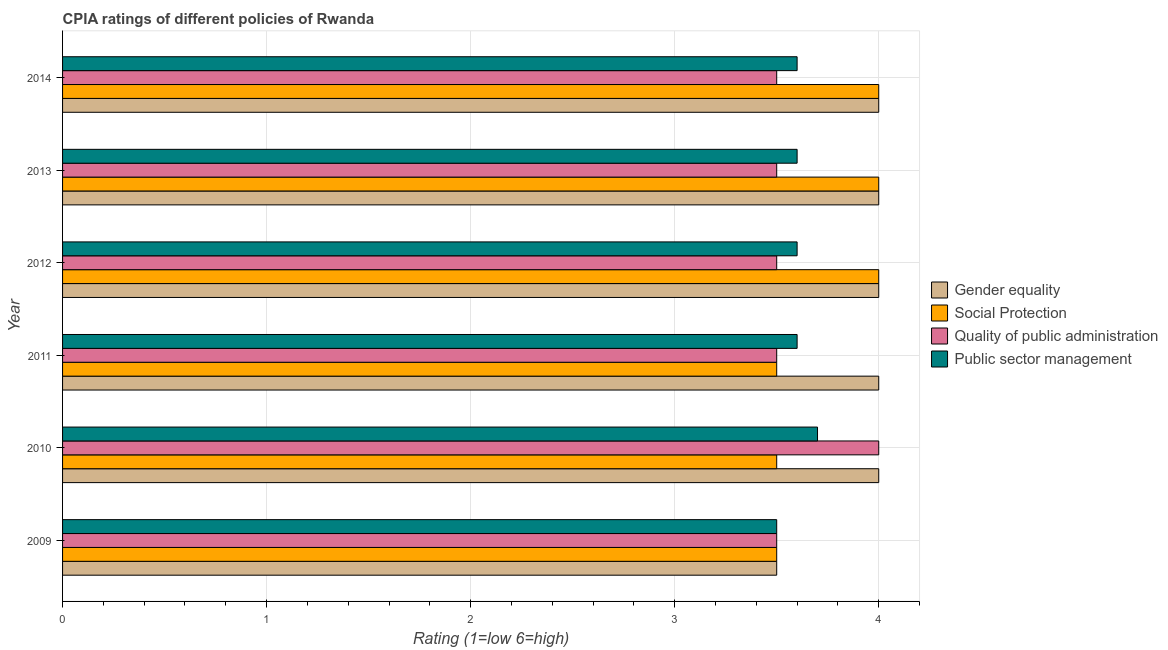How many groups of bars are there?
Give a very brief answer. 6. Are the number of bars on each tick of the Y-axis equal?
Your answer should be very brief. Yes. How many bars are there on the 5th tick from the top?
Offer a very short reply. 4. What is the cpia rating of gender equality in 2010?
Offer a very short reply. 4. In which year was the cpia rating of quality of public administration minimum?
Make the answer very short. 2009. What is the difference between the cpia rating of quality of public administration in 2014 and the cpia rating of gender equality in 2010?
Ensure brevity in your answer.  -0.5. What is the average cpia rating of public sector management per year?
Make the answer very short. 3.6. In how many years, is the cpia rating of gender equality greater than 1.8 ?
Offer a terse response. 6. What is the ratio of the cpia rating of gender equality in 2009 to that in 2014?
Your answer should be compact. 0.88. Is the cpia rating of social protection in 2009 less than that in 2010?
Keep it short and to the point. No. Is the difference between the cpia rating of social protection in 2009 and 2011 greater than the difference between the cpia rating of public sector management in 2009 and 2011?
Make the answer very short. Yes. What does the 1st bar from the top in 2013 represents?
Your response must be concise. Public sector management. What does the 4th bar from the bottom in 2012 represents?
Ensure brevity in your answer.  Public sector management. How many bars are there?
Offer a terse response. 24. Are all the bars in the graph horizontal?
Provide a short and direct response. Yes. What is the difference between two consecutive major ticks on the X-axis?
Make the answer very short. 1. How many legend labels are there?
Your response must be concise. 4. What is the title of the graph?
Provide a short and direct response. CPIA ratings of different policies of Rwanda. Does "Public sector management" appear as one of the legend labels in the graph?
Offer a terse response. Yes. What is the label or title of the X-axis?
Your answer should be very brief. Rating (1=low 6=high). What is the Rating (1=low 6=high) in Gender equality in 2009?
Make the answer very short. 3.5. What is the Rating (1=low 6=high) in Social Protection in 2009?
Your answer should be very brief. 3.5. What is the Rating (1=low 6=high) of Quality of public administration in 2009?
Offer a very short reply. 3.5. What is the Rating (1=low 6=high) in Gender equality in 2010?
Offer a very short reply. 4. What is the Rating (1=low 6=high) in Quality of public administration in 2010?
Your response must be concise. 4. What is the Rating (1=low 6=high) of Public sector management in 2010?
Provide a succinct answer. 3.7. What is the Rating (1=low 6=high) in Social Protection in 2011?
Offer a terse response. 3.5. What is the Rating (1=low 6=high) in Public sector management in 2011?
Keep it short and to the point. 3.6. What is the Rating (1=low 6=high) in Quality of public administration in 2012?
Keep it short and to the point. 3.5. What is the Rating (1=low 6=high) in Public sector management in 2012?
Ensure brevity in your answer.  3.6. What is the Rating (1=low 6=high) in Gender equality in 2013?
Your response must be concise. 4. What is the Rating (1=low 6=high) in Public sector management in 2013?
Your answer should be very brief. 3.6. What is the Rating (1=low 6=high) of Social Protection in 2014?
Keep it short and to the point. 4. What is the Rating (1=low 6=high) in Quality of public administration in 2014?
Keep it short and to the point. 3.5. Across all years, what is the maximum Rating (1=low 6=high) of Social Protection?
Offer a terse response. 4. Across all years, what is the maximum Rating (1=low 6=high) of Quality of public administration?
Your answer should be compact. 4. Across all years, what is the maximum Rating (1=low 6=high) of Public sector management?
Make the answer very short. 3.7. Across all years, what is the minimum Rating (1=low 6=high) of Social Protection?
Offer a very short reply. 3.5. Across all years, what is the minimum Rating (1=low 6=high) of Quality of public administration?
Your answer should be very brief. 3.5. What is the total Rating (1=low 6=high) in Social Protection in the graph?
Offer a very short reply. 22.5. What is the total Rating (1=low 6=high) of Public sector management in the graph?
Make the answer very short. 21.6. What is the difference between the Rating (1=low 6=high) in Social Protection in 2009 and that in 2010?
Your answer should be very brief. 0. What is the difference between the Rating (1=low 6=high) in Quality of public administration in 2009 and that in 2010?
Ensure brevity in your answer.  -0.5. What is the difference between the Rating (1=low 6=high) in Public sector management in 2009 and that in 2010?
Ensure brevity in your answer.  -0.2. What is the difference between the Rating (1=low 6=high) of Gender equality in 2009 and that in 2011?
Provide a succinct answer. -0.5. What is the difference between the Rating (1=low 6=high) of Social Protection in 2009 and that in 2011?
Offer a terse response. 0. What is the difference between the Rating (1=low 6=high) in Quality of public administration in 2009 and that in 2011?
Your response must be concise. 0. What is the difference between the Rating (1=low 6=high) of Gender equality in 2009 and that in 2013?
Give a very brief answer. -0.5. What is the difference between the Rating (1=low 6=high) of Quality of public administration in 2009 and that in 2013?
Keep it short and to the point. 0. What is the difference between the Rating (1=low 6=high) of Public sector management in 2009 and that in 2013?
Give a very brief answer. -0.1. What is the difference between the Rating (1=low 6=high) of Social Protection in 2009 and that in 2014?
Give a very brief answer. -0.5. What is the difference between the Rating (1=low 6=high) in Gender equality in 2010 and that in 2011?
Your answer should be very brief. 0. What is the difference between the Rating (1=low 6=high) of Social Protection in 2010 and that in 2011?
Provide a succinct answer. 0. What is the difference between the Rating (1=low 6=high) of Public sector management in 2010 and that in 2011?
Your response must be concise. 0.1. What is the difference between the Rating (1=low 6=high) of Social Protection in 2010 and that in 2012?
Offer a terse response. -0.5. What is the difference between the Rating (1=low 6=high) of Quality of public administration in 2010 and that in 2012?
Your response must be concise. 0.5. What is the difference between the Rating (1=low 6=high) of Public sector management in 2010 and that in 2012?
Offer a terse response. 0.1. What is the difference between the Rating (1=low 6=high) of Social Protection in 2010 and that in 2014?
Offer a terse response. -0.5. What is the difference between the Rating (1=low 6=high) in Quality of public administration in 2011 and that in 2012?
Offer a terse response. 0. What is the difference between the Rating (1=low 6=high) of Public sector management in 2011 and that in 2012?
Offer a very short reply. 0. What is the difference between the Rating (1=low 6=high) of Gender equality in 2011 and that in 2013?
Provide a succinct answer. 0. What is the difference between the Rating (1=low 6=high) of Quality of public administration in 2011 and that in 2013?
Give a very brief answer. 0. What is the difference between the Rating (1=low 6=high) of Quality of public administration in 2011 and that in 2014?
Provide a succinct answer. 0. What is the difference between the Rating (1=low 6=high) of Gender equality in 2012 and that in 2013?
Keep it short and to the point. 0. What is the difference between the Rating (1=low 6=high) in Social Protection in 2012 and that in 2013?
Your answer should be compact. 0. What is the difference between the Rating (1=low 6=high) in Gender equality in 2012 and that in 2014?
Keep it short and to the point. 0. What is the difference between the Rating (1=low 6=high) of Social Protection in 2012 and that in 2014?
Your answer should be very brief. 0. What is the difference between the Rating (1=low 6=high) in Public sector management in 2012 and that in 2014?
Keep it short and to the point. 0. What is the difference between the Rating (1=low 6=high) of Gender equality in 2009 and the Rating (1=low 6=high) of Public sector management in 2010?
Provide a succinct answer. -0.2. What is the difference between the Rating (1=low 6=high) in Social Protection in 2009 and the Rating (1=low 6=high) in Quality of public administration in 2010?
Your response must be concise. -0.5. What is the difference between the Rating (1=low 6=high) in Social Protection in 2009 and the Rating (1=low 6=high) in Public sector management in 2010?
Keep it short and to the point. -0.2. What is the difference between the Rating (1=low 6=high) of Quality of public administration in 2009 and the Rating (1=low 6=high) of Public sector management in 2010?
Your response must be concise. -0.2. What is the difference between the Rating (1=low 6=high) in Gender equality in 2009 and the Rating (1=low 6=high) in Social Protection in 2011?
Your answer should be compact. 0. What is the difference between the Rating (1=low 6=high) of Gender equality in 2009 and the Rating (1=low 6=high) of Public sector management in 2011?
Your answer should be very brief. -0.1. What is the difference between the Rating (1=low 6=high) of Social Protection in 2009 and the Rating (1=low 6=high) of Quality of public administration in 2011?
Ensure brevity in your answer.  0. What is the difference between the Rating (1=low 6=high) in Social Protection in 2009 and the Rating (1=low 6=high) in Public sector management in 2011?
Give a very brief answer. -0.1. What is the difference between the Rating (1=low 6=high) in Gender equality in 2009 and the Rating (1=low 6=high) in Social Protection in 2012?
Your response must be concise. -0.5. What is the difference between the Rating (1=low 6=high) in Gender equality in 2009 and the Rating (1=low 6=high) in Public sector management in 2012?
Keep it short and to the point. -0.1. What is the difference between the Rating (1=low 6=high) of Social Protection in 2009 and the Rating (1=low 6=high) of Quality of public administration in 2012?
Your answer should be very brief. 0. What is the difference between the Rating (1=low 6=high) of Social Protection in 2009 and the Rating (1=low 6=high) of Public sector management in 2012?
Your response must be concise. -0.1. What is the difference between the Rating (1=low 6=high) in Social Protection in 2009 and the Rating (1=low 6=high) in Public sector management in 2013?
Your answer should be compact. -0.1. What is the difference between the Rating (1=low 6=high) of Quality of public administration in 2009 and the Rating (1=low 6=high) of Public sector management in 2013?
Provide a short and direct response. -0.1. What is the difference between the Rating (1=low 6=high) of Gender equality in 2009 and the Rating (1=low 6=high) of Social Protection in 2014?
Make the answer very short. -0.5. What is the difference between the Rating (1=low 6=high) of Quality of public administration in 2009 and the Rating (1=low 6=high) of Public sector management in 2014?
Provide a short and direct response. -0.1. What is the difference between the Rating (1=low 6=high) of Gender equality in 2010 and the Rating (1=low 6=high) of Social Protection in 2011?
Offer a very short reply. 0.5. What is the difference between the Rating (1=low 6=high) in Social Protection in 2010 and the Rating (1=low 6=high) in Quality of public administration in 2011?
Your answer should be compact. 0. What is the difference between the Rating (1=low 6=high) in Quality of public administration in 2010 and the Rating (1=low 6=high) in Public sector management in 2011?
Keep it short and to the point. 0.4. What is the difference between the Rating (1=low 6=high) of Social Protection in 2010 and the Rating (1=low 6=high) of Quality of public administration in 2012?
Offer a terse response. 0. What is the difference between the Rating (1=low 6=high) of Gender equality in 2010 and the Rating (1=low 6=high) of Social Protection in 2013?
Offer a terse response. 0. What is the difference between the Rating (1=low 6=high) in Social Protection in 2010 and the Rating (1=low 6=high) in Public sector management in 2013?
Offer a very short reply. -0.1. What is the difference between the Rating (1=low 6=high) in Quality of public administration in 2010 and the Rating (1=low 6=high) in Public sector management in 2013?
Give a very brief answer. 0.4. What is the difference between the Rating (1=low 6=high) of Gender equality in 2010 and the Rating (1=low 6=high) of Social Protection in 2014?
Your answer should be compact. 0. What is the difference between the Rating (1=low 6=high) of Gender equality in 2010 and the Rating (1=low 6=high) of Quality of public administration in 2014?
Offer a very short reply. 0.5. What is the difference between the Rating (1=low 6=high) of Quality of public administration in 2010 and the Rating (1=low 6=high) of Public sector management in 2014?
Give a very brief answer. 0.4. What is the difference between the Rating (1=low 6=high) of Gender equality in 2011 and the Rating (1=low 6=high) of Public sector management in 2012?
Ensure brevity in your answer.  0.4. What is the difference between the Rating (1=low 6=high) of Social Protection in 2011 and the Rating (1=low 6=high) of Quality of public administration in 2012?
Give a very brief answer. 0. What is the difference between the Rating (1=low 6=high) of Quality of public administration in 2011 and the Rating (1=low 6=high) of Public sector management in 2012?
Provide a short and direct response. -0.1. What is the difference between the Rating (1=low 6=high) in Gender equality in 2011 and the Rating (1=low 6=high) in Social Protection in 2013?
Your answer should be compact. 0. What is the difference between the Rating (1=low 6=high) in Gender equality in 2011 and the Rating (1=low 6=high) in Public sector management in 2013?
Your response must be concise. 0.4. What is the difference between the Rating (1=low 6=high) in Quality of public administration in 2011 and the Rating (1=low 6=high) in Public sector management in 2013?
Offer a terse response. -0.1. What is the difference between the Rating (1=low 6=high) in Gender equality in 2011 and the Rating (1=low 6=high) in Social Protection in 2014?
Your response must be concise. 0. What is the difference between the Rating (1=low 6=high) in Gender equality in 2011 and the Rating (1=low 6=high) in Quality of public administration in 2014?
Your answer should be compact. 0.5. What is the difference between the Rating (1=low 6=high) in Social Protection in 2011 and the Rating (1=low 6=high) in Quality of public administration in 2014?
Your answer should be compact. 0. What is the difference between the Rating (1=low 6=high) in Quality of public administration in 2011 and the Rating (1=low 6=high) in Public sector management in 2014?
Keep it short and to the point. -0.1. What is the difference between the Rating (1=low 6=high) of Gender equality in 2012 and the Rating (1=low 6=high) of Social Protection in 2013?
Provide a succinct answer. 0. What is the difference between the Rating (1=low 6=high) of Gender equality in 2012 and the Rating (1=low 6=high) of Quality of public administration in 2013?
Provide a short and direct response. 0.5. What is the difference between the Rating (1=low 6=high) in Gender equality in 2012 and the Rating (1=low 6=high) in Social Protection in 2014?
Give a very brief answer. 0. What is the difference between the Rating (1=low 6=high) in Gender equality in 2012 and the Rating (1=low 6=high) in Quality of public administration in 2014?
Your answer should be compact. 0.5. What is the difference between the Rating (1=low 6=high) of Quality of public administration in 2012 and the Rating (1=low 6=high) of Public sector management in 2014?
Offer a terse response. -0.1. What is the difference between the Rating (1=low 6=high) of Gender equality in 2013 and the Rating (1=low 6=high) of Social Protection in 2014?
Ensure brevity in your answer.  0. What is the difference between the Rating (1=low 6=high) of Social Protection in 2013 and the Rating (1=low 6=high) of Public sector management in 2014?
Ensure brevity in your answer.  0.4. What is the difference between the Rating (1=low 6=high) in Quality of public administration in 2013 and the Rating (1=low 6=high) in Public sector management in 2014?
Offer a terse response. -0.1. What is the average Rating (1=low 6=high) of Gender equality per year?
Ensure brevity in your answer.  3.92. What is the average Rating (1=low 6=high) of Social Protection per year?
Your response must be concise. 3.75. What is the average Rating (1=low 6=high) in Quality of public administration per year?
Make the answer very short. 3.58. What is the average Rating (1=low 6=high) in Public sector management per year?
Your answer should be compact. 3.6. In the year 2009, what is the difference between the Rating (1=low 6=high) in Gender equality and Rating (1=low 6=high) in Quality of public administration?
Your answer should be very brief. 0. In the year 2009, what is the difference between the Rating (1=low 6=high) in Social Protection and Rating (1=low 6=high) in Quality of public administration?
Ensure brevity in your answer.  0. In the year 2010, what is the difference between the Rating (1=low 6=high) in Gender equality and Rating (1=low 6=high) in Quality of public administration?
Offer a very short reply. 0. In the year 2010, what is the difference between the Rating (1=low 6=high) in Social Protection and Rating (1=low 6=high) in Public sector management?
Provide a short and direct response. -0.2. In the year 2010, what is the difference between the Rating (1=low 6=high) in Quality of public administration and Rating (1=low 6=high) in Public sector management?
Provide a short and direct response. 0.3. In the year 2011, what is the difference between the Rating (1=low 6=high) of Gender equality and Rating (1=low 6=high) of Social Protection?
Provide a succinct answer. 0.5. In the year 2011, what is the difference between the Rating (1=low 6=high) in Gender equality and Rating (1=low 6=high) in Quality of public administration?
Ensure brevity in your answer.  0.5. In the year 2011, what is the difference between the Rating (1=low 6=high) in Social Protection and Rating (1=low 6=high) in Quality of public administration?
Offer a very short reply. 0. In the year 2011, what is the difference between the Rating (1=low 6=high) in Social Protection and Rating (1=low 6=high) in Public sector management?
Offer a very short reply. -0.1. In the year 2011, what is the difference between the Rating (1=low 6=high) of Quality of public administration and Rating (1=low 6=high) of Public sector management?
Offer a terse response. -0.1. In the year 2012, what is the difference between the Rating (1=low 6=high) of Gender equality and Rating (1=low 6=high) of Social Protection?
Make the answer very short. 0. In the year 2012, what is the difference between the Rating (1=low 6=high) of Gender equality and Rating (1=low 6=high) of Quality of public administration?
Your answer should be compact. 0.5. In the year 2012, what is the difference between the Rating (1=low 6=high) in Gender equality and Rating (1=low 6=high) in Public sector management?
Offer a very short reply. 0.4. In the year 2012, what is the difference between the Rating (1=low 6=high) in Social Protection and Rating (1=low 6=high) in Quality of public administration?
Ensure brevity in your answer.  0.5. In the year 2012, what is the difference between the Rating (1=low 6=high) in Quality of public administration and Rating (1=low 6=high) in Public sector management?
Keep it short and to the point. -0.1. In the year 2013, what is the difference between the Rating (1=low 6=high) of Gender equality and Rating (1=low 6=high) of Social Protection?
Your response must be concise. 0. In the year 2013, what is the difference between the Rating (1=low 6=high) of Gender equality and Rating (1=low 6=high) of Quality of public administration?
Keep it short and to the point. 0.5. In the year 2013, what is the difference between the Rating (1=low 6=high) in Social Protection and Rating (1=low 6=high) in Quality of public administration?
Offer a terse response. 0.5. In the year 2014, what is the difference between the Rating (1=low 6=high) of Gender equality and Rating (1=low 6=high) of Quality of public administration?
Keep it short and to the point. 0.5. What is the ratio of the Rating (1=low 6=high) in Social Protection in 2009 to that in 2010?
Provide a short and direct response. 1. What is the ratio of the Rating (1=low 6=high) of Public sector management in 2009 to that in 2010?
Provide a succinct answer. 0.95. What is the ratio of the Rating (1=low 6=high) of Social Protection in 2009 to that in 2011?
Provide a short and direct response. 1. What is the ratio of the Rating (1=low 6=high) in Public sector management in 2009 to that in 2011?
Keep it short and to the point. 0.97. What is the ratio of the Rating (1=low 6=high) of Gender equality in 2009 to that in 2012?
Ensure brevity in your answer.  0.88. What is the ratio of the Rating (1=low 6=high) of Public sector management in 2009 to that in 2012?
Ensure brevity in your answer.  0.97. What is the ratio of the Rating (1=low 6=high) in Social Protection in 2009 to that in 2013?
Your answer should be compact. 0.88. What is the ratio of the Rating (1=low 6=high) in Quality of public administration in 2009 to that in 2013?
Your answer should be compact. 1. What is the ratio of the Rating (1=low 6=high) in Public sector management in 2009 to that in 2013?
Your answer should be compact. 0.97. What is the ratio of the Rating (1=low 6=high) in Gender equality in 2009 to that in 2014?
Keep it short and to the point. 0.88. What is the ratio of the Rating (1=low 6=high) of Quality of public administration in 2009 to that in 2014?
Keep it short and to the point. 1. What is the ratio of the Rating (1=low 6=high) of Public sector management in 2009 to that in 2014?
Give a very brief answer. 0.97. What is the ratio of the Rating (1=low 6=high) of Gender equality in 2010 to that in 2011?
Ensure brevity in your answer.  1. What is the ratio of the Rating (1=low 6=high) in Social Protection in 2010 to that in 2011?
Your answer should be very brief. 1. What is the ratio of the Rating (1=low 6=high) of Public sector management in 2010 to that in 2011?
Provide a short and direct response. 1.03. What is the ratio of the Rating (1=low 6=high) of Social Protection in 2010 to that in 2012?
Your answer should be compact. 0.88. What is the ratio of the Rating (1=low 6=high) in Public sector management in 2010 to that in 2012?
Give a very brief answer. 1.03. What is the ratio of the Rating (1=low 6=high) in Quality of public administration in 2010 to that in 2013?
Provide a short and direct response. 1.14. What is the ratio of the Rating (1=low 6=high) of Public sector management in 2010 to that in 2013?
Provide a succinct answer. 1.03. What is the ratio of the Rating (1=low 6=high) in Gender equality in 2010 to that in 2014?
Keep it short and to the point. 1. What is the ratio of the Rating (1=low 6=high) in Quality of public administration in 2010 to that in 2014?
Provide a short and direct response. 1.14. What is the ratio of the Rating (1=low 6=high) of Public sector management in 2010 to that in 2014?
Ensure brevity in your answer.  1.03. What is the ratio of the Rating (1=low 6=high) of Quality of public administration in 2011 to that in 2012?
Keep it short and to the point. 1. What is the ratio of the Rating (1=low 6=high) of Social Protection in 2011 to that in 2013?
Provide a short and direct response. 0.88. What is the ratio of the Rating (1=low 6=high) of Quality of public administration in 2011 to that in 2014?
Keep it short and to the point. 1. What is the ratio of the Rating (1=low 6=high) of Gender equality in 2012 to that in 2013?
Provide a short and direct response. 1. What is the ratio of the Rating (1=low 6=high) of Gender equality in 2012 to that in 2014?
Ensure brevity in your answer.  1. What is the ratio of the Rating (1=low 6=high) of Gender equality in 2013 to that in 2014?
Your answer should be very brief. 1. What is the ratio of the Rating (1=low 6=high) of Social Protection in 2013 to that in 2014?
Offer a terse response. 1. What is the ratio of the Rating (1=low 6=high) of Quality of public administration in 2013 to that in 2014?
Your answer should be compact. 1. What is the difference between the highest and the second highest Rating (1=low 6=high) of Gender equality?
Give a very brief answer. 0. What is the difference between the highest and the second highest Rating (1=low 6=high) of Social Protection?
Give a very brief answer. 0. What is the difference between the highest and the lowest Rating (1=low 6=high) in Gender equality?
Offer a very short reply. 0.5. What is the difference between the highest and the lowest Rating (1=low 6=high) of Social Protection?
Ensure brevity in your answer.  0.5. 